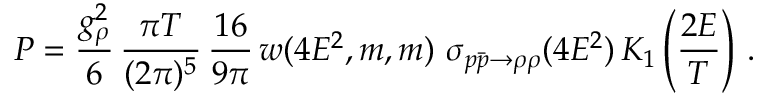Convert formula to latex. <formula><loc_0><loc_0><loc_500><loc_500>P = { \frac { g _ { \rho } ^ { 2 } } { 6 } } \, \frac { \pi T } { ( 2 \pi ) ^ { 5 } } \, \frac { 1 6 } { 9 \pi } \, w ( 4 E ^ { 2 } , m , m ) \ \sigma _ { p \bar { p } \rightarrow \rho \rho } ( 4 E ^ { 2 } ) \, K _ { 1 } \left ( \frac { 2 E } { T } \right ) \, .</formula> 